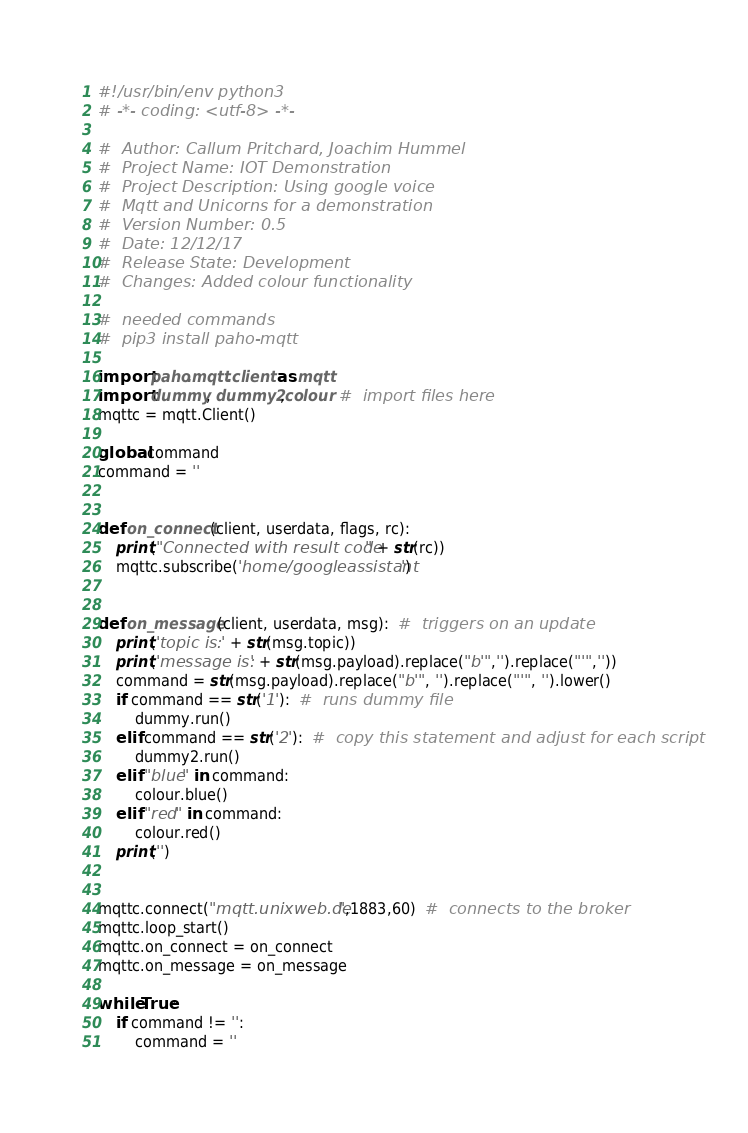<code> <loc_0><loc_0><loc_500><loc_500><_Python_>#!/usr/bin/env python3
# -*- coding: <utf-8> -*-

#  Author: Callum Pritchard, Joachim Hummel
#  Project Name: IOT Demonstration
#  Project Description: Using google voice
#  Mqtt and Unicorns for a demonstration
#  Version Number: 0.5
#  Date: 12/12/17
#  Release State: Development
#  Changes: Added colour functionality

#  needed commands
#  pip3 install paho-mqtt

import paho.mqtt.client as mqtt
import dummy, dummy2,colour  #  import files here
mqttc = mqtt.Client()

global command
command = ''


def on_connect(client, userdata, flags, rc):
    print("Connected with result code " + str(rc))
    mqttc.subscribe('home/googleassistant')


def on_message(client, userdata, msg):  #  triggers on an update
    print('topic is: ' + str(msg.topic))
    print('message is: ' + str(msg.payload).replace("b'",'').replace("'",''))
    command = str(msg.payload).replace("b'", '').replace("'", '').lower()
    if command == str('1'):  #  runs dummy file
        dummy.run()
    elif command == str('2'):  #  copy this statement and adjust for each script
        dummy2.run()
    elif "blue" in command:
        colour.blue()
    elif "red" in command:
        colour.red()
    print('')


mqttc.connect("mqtt.unixweb.de",1883,60)  #  connects to the broker
mqttc.loop_start()
mqttc.on_connect = on_connect
mqttc.on_message = on_message

while True:
    if command != '':
        command = ''
</code> 